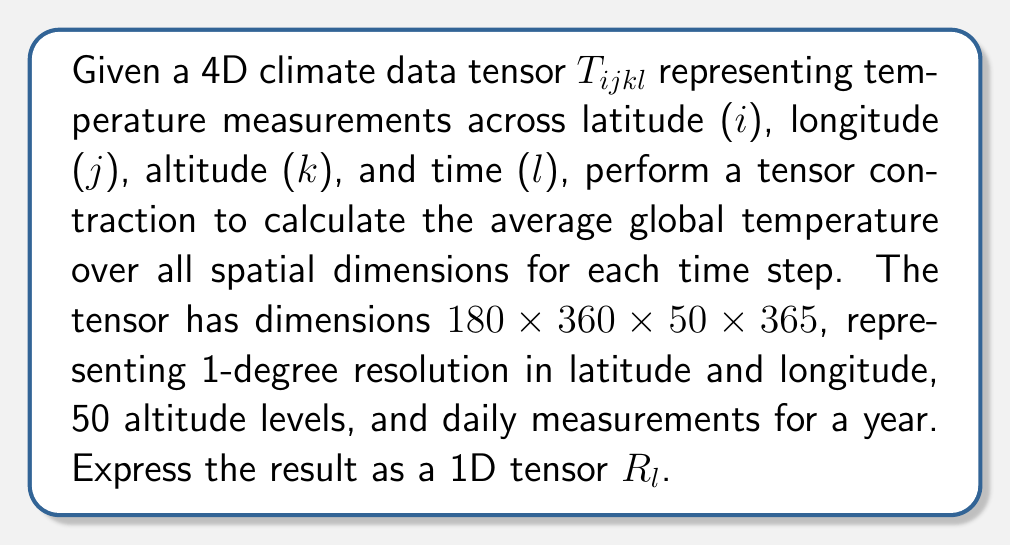What is the answer to this math problem? To solve this problem, we need to perform a tensor contraction over the spatial dimensions (latitude, longitude, and altitude) while preserving the time dimension. Here's a step-by-step approach:

1) The tensor contraction we need to perform can be expressed mathematically as:

   $$R_l = \frac{1}{N} \sum_{i=1}^{180} \sum_{j=1}^{360} \sum_{k=1}^{50} T_{ijkl}$$

   where $N = 180 \times 360 \times 50 = 3,240,000$ is the total number of spatial points.

2) This operation reduces the 4D tensor $T_{ijkl}$ to a 1D tensor $R_l$ by summing over the $i$, $j$, and $k$ indices and dividing by the total number of spatial points.

3) The resulting tensor $R_l$ will have a dimension of 365, corresponding to the daily average global temperature for each day of the year.

4) In terms of implementation, this could be achieved through nested loops or using optimized tensor libraries that support such operations.

5) The units of $R_l$ would be the same as the original temperature measurements in $T_{ijkl}$, typically degrees Celsius or Kelvin.

6) This contraction effectively calculates the global average temperature for each day, considering all spatial points equally. It's worth noting that in real-world applications, you might want to consider area-weighted averages due to the difference in area represented by each lat-lon grid cell.
Answer: $$R_l = \frac{1}{3,240,000} \sum_{i=1}^{180} \sum_{j=1}^{360} \sum_{k=1}^{50} T_{ijkl}$$ 